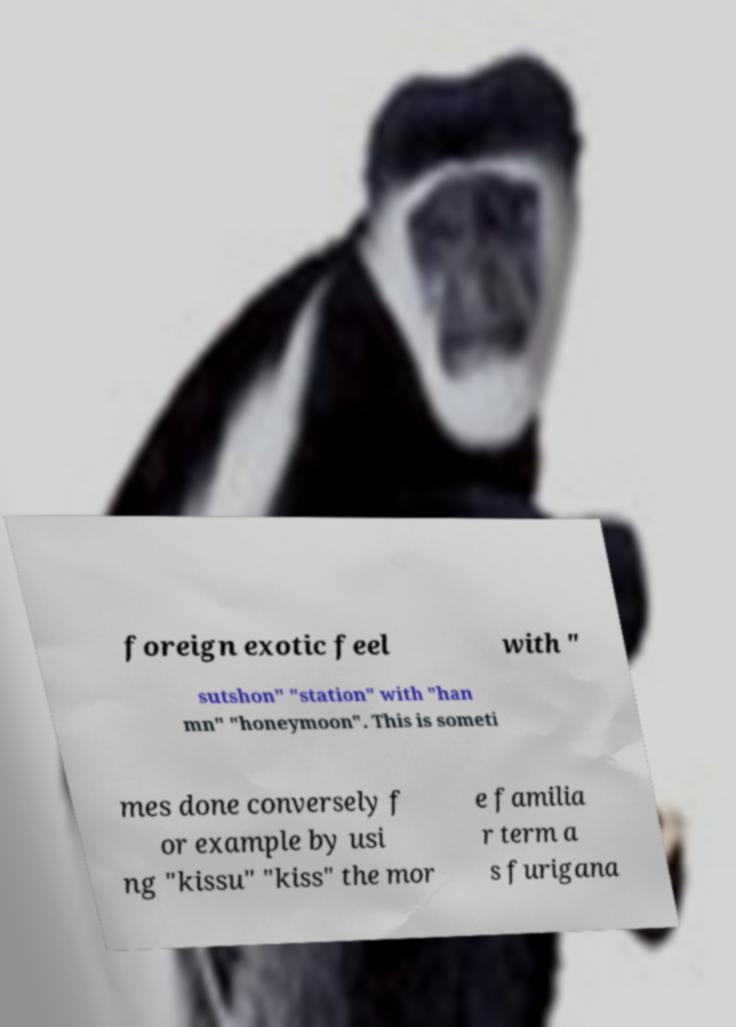Can you read and provide the text displayed in the image?This photo seems to have some interesting text. Can you extract and type it out for me? foreign exotic feel with " sutshon" "station" with "han mn" "honeymoon". This is someti mes done conversely f or example by usi ng "kissu" "kiss" the mor e familia r term a s furigana 